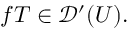<formula> <loc_0><loc_0><loc_500><loc_500>f T \in { \mathcal { D } } ^ { \prime } ( U ) .</formula> 